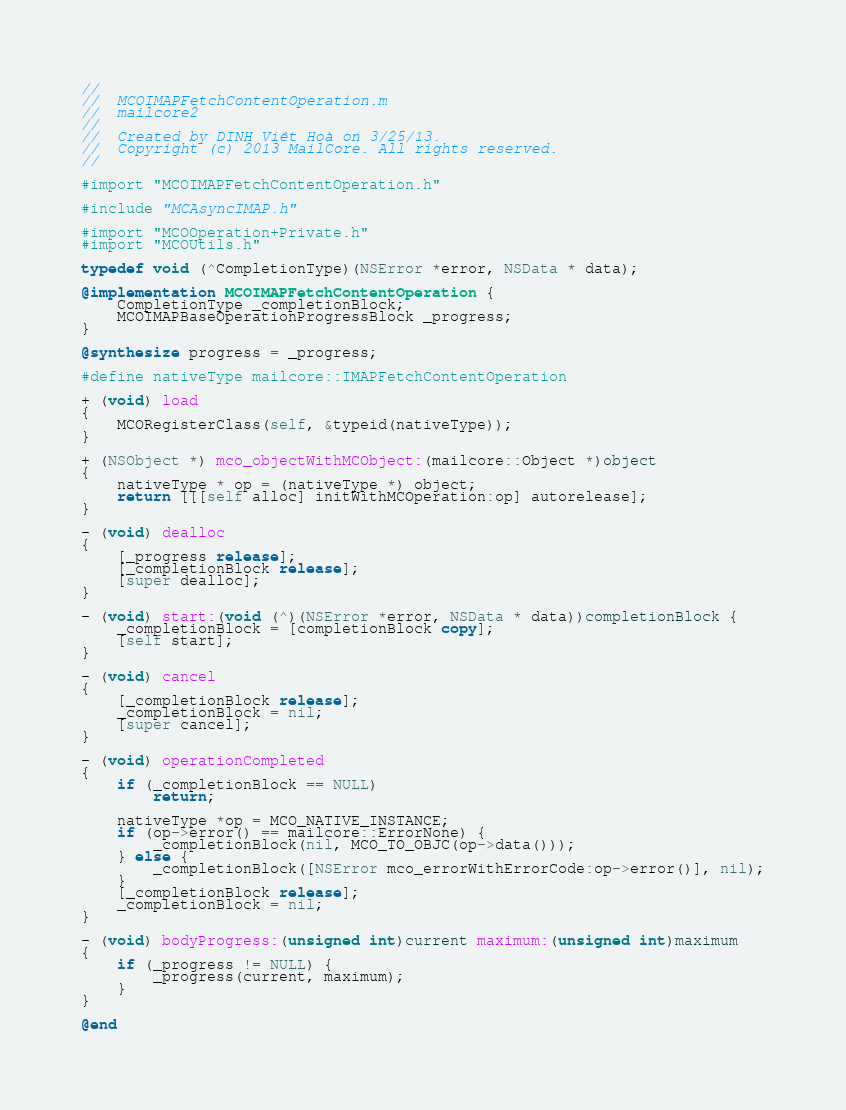<code> <loc_0><loc_0><loc_500><loc_500><_ObjectiveC_>//
//  MCOIMAPFetchContentOperation.m
//  mailcore2
//
//  Created by DINH Viêt Hoà on 3/25/13.
//  Copyright (c) 2013 MailCore. All rights reserved.
//

#import "MCOIMAPFetchContentOperation.h"

#include "MCAsyncIMAP.h"

#import "MCOOperation+Private.h"
#import "MCOUtils.h"

typedef void (^CompletionType)(NSError *error, NSData * data);

@implementation MCOIMAPFetchContentOperation {
    CompletionType _completionBlock;
    MCOIMAPBaseOperationProgressBlock _progress;
}

@synthesize progress = _progress;

#define nativeType mailcore::IMAPFetchContentOperation

+ (void) load
{
    MCORegisterClass(self, &typeid(nativeType));
}

+ (NSObject *) mco_objectWithMCObject:(mailcore::Object *)object
{
    nativeType * op = (nativeType *) object;
    return [[[self alloc] initWithMCOperation:op] autorelease];
}

- (void) dealloc
{
    [_progress release];
    [_completionBlock release];
    [super dealloc];
}

- (void) start:(void (^)(NSError *error, NSData * data))completionBlock {
    _completionBlock = [completionBlock copy];
    [self start];
}

- (void) cancel
{
    [_completionBlock release];
    _completionBlock = nil;
    [super cancel];
}

- (void) operationCompleted
{
    if (_completionBlock == NULL)
        return;
    
    nativeType *op = MCO_NATIVE_INSTANCE;
    if (op->error() == mailcore::ErrorNone) {
        _completionBlock(nil, MCO_TO_OBJC(op->data()));
    } else {
        _completionBlock([NSError mco_errorWithErrorCode:op->error()], nil);
    }
    [_completionBlock release];
    _completionBlock = nil;
}

- (void) bodyProgress:(unsigned int)current maximum:(unsigned int)maximum
{
    if (_progress != NULL) {
        _progress(current, maximum);
    }
}

@end
</code> 